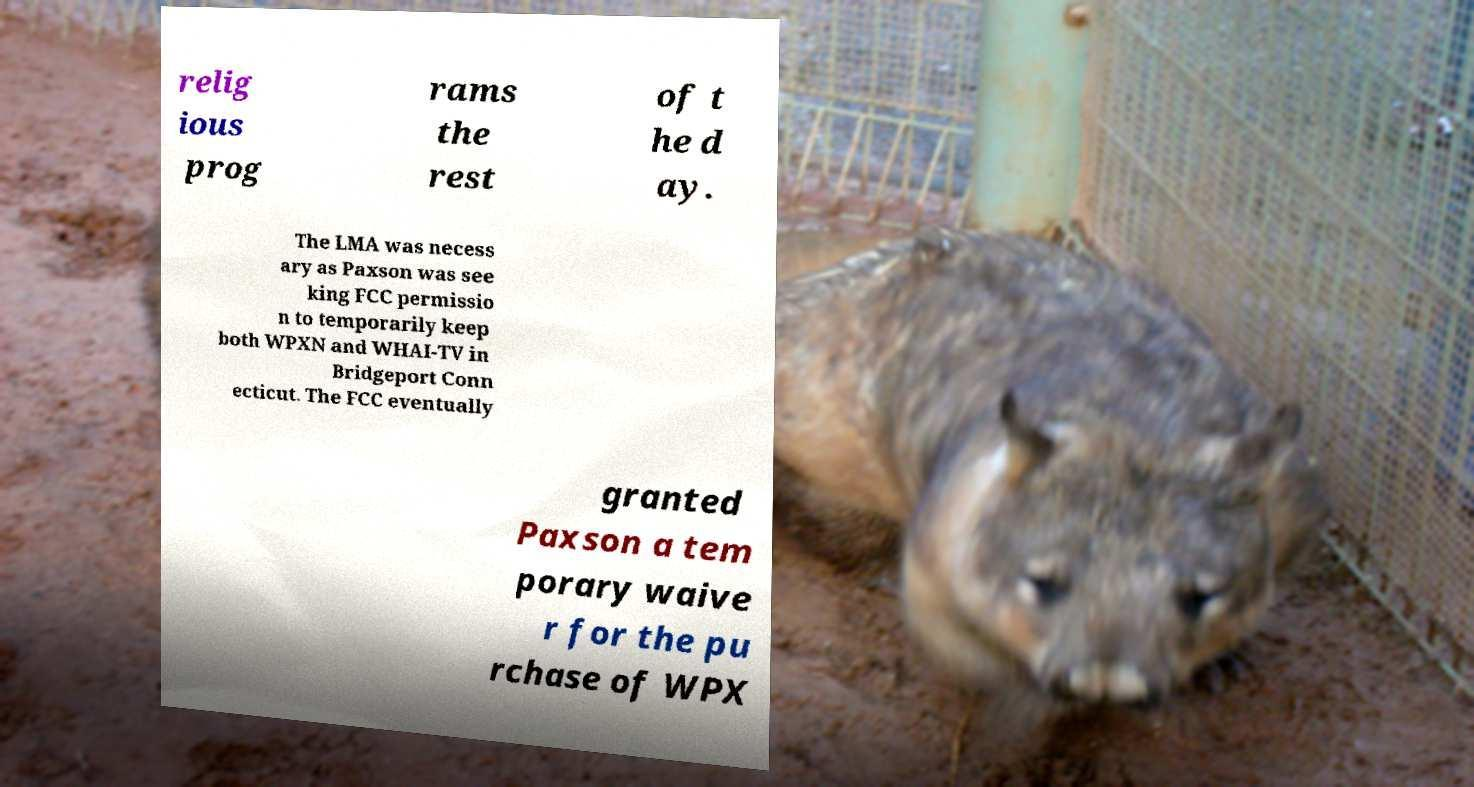Please identify and transcribe the text found in this image. relig ious prog rams the rest of t he d ay. The LMA was necess ary as Paxson was see king FCC permissio n to temporarily keep both WPXN and WHAI-TV in Bridgeport Conn ecticut. The FCC eventually granted Paxson a tem porary waive r for the pu rchase of WPX 